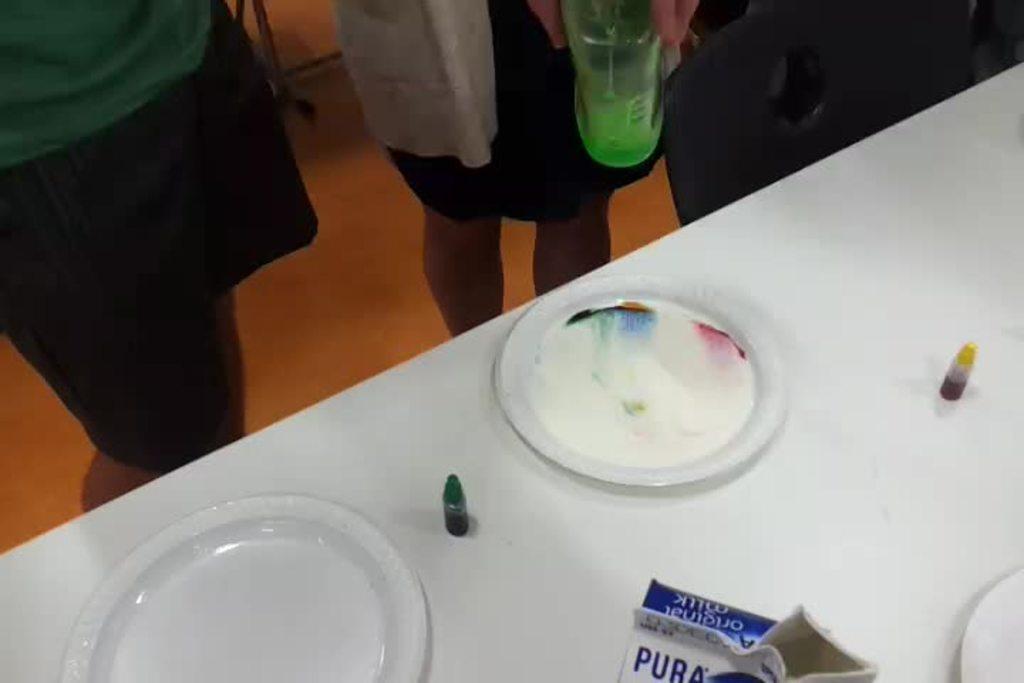How would you summarize this image in a sentence or two? This picture is of inside. On the right there is a table on the top of which box, small bottles and plates are placed. On the top there are two persons standing. In the background we can see a wall and a floor. 